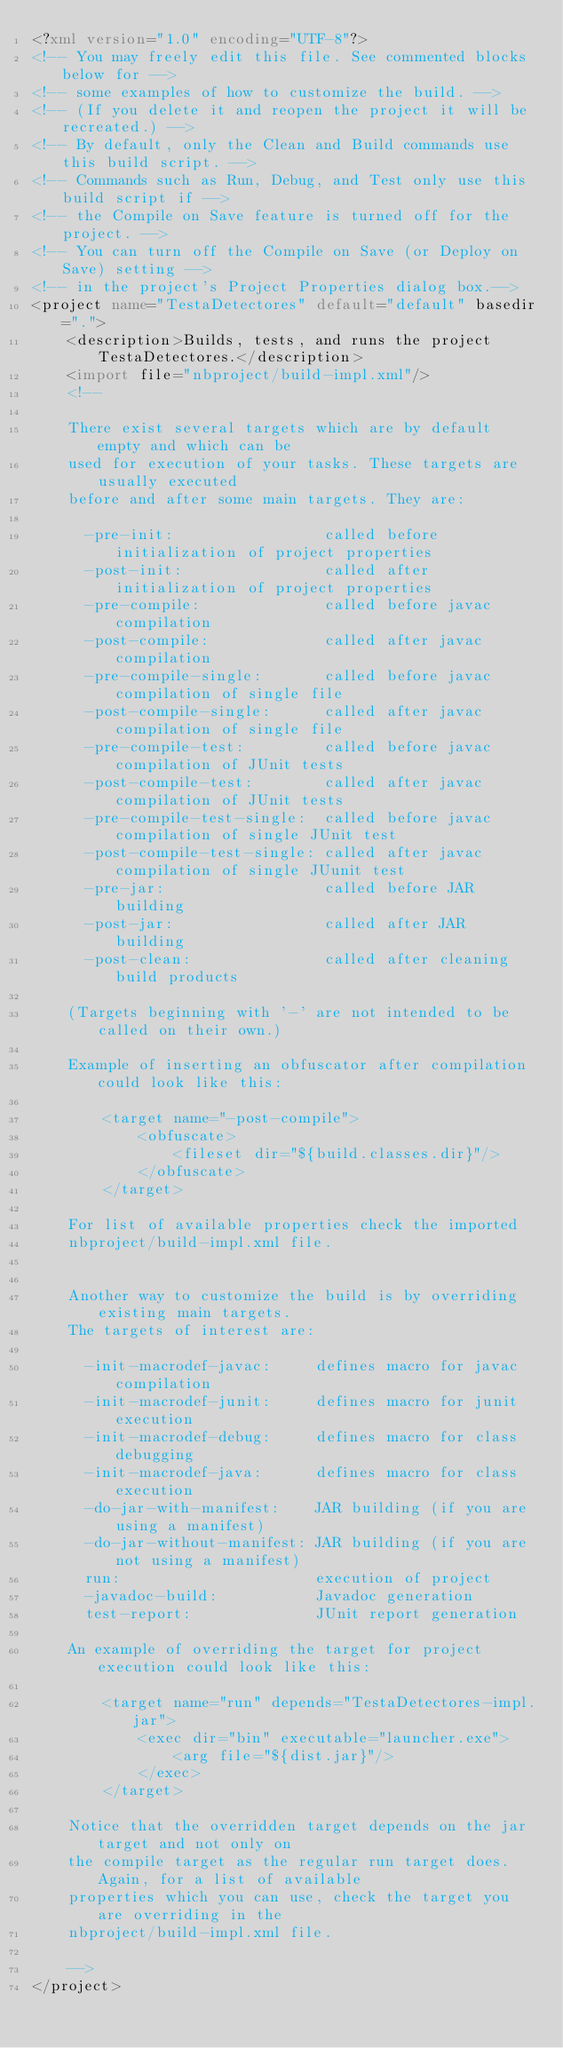<code> <loc_0><loc_0><loc_500><loc_500><_XML_><?xml version="1.0" encoding="UTF-8"?>
<!-- You may freely edit this file. See commented blocks below for -->
<!-- some examples of how to customize the build. -->
<!-- (If you delete it and reopen the project it will be recreated.) -->
<!-- By default, only the Clean and Build commands use this build script. -->
<!-- Commands such as Run, Debug, and Test only use this build script if -->
<!-- the Compile on Save feature is turned off for the project. -->
<!-- You can turn off the Compile on Save (or Deploy on Save) setting -->
<!-- in the project's Project Properties dialog box.-->
<project name="TestaDetectores" default="default" basedir=".">
    <description>Builds, tests, and runs the project TestaDetectores.</description>
    <import file="nbproject/build-impl.xml"/>
    <!--

    There exist several targets which are by default empty and which can be 
    used for execution of your tasks. These targets are usually executed 
    before and after some main targets. They are: 

      -pre-init:                 called before initialization of project properties
      -post-init:                called after initialization of project properties
      -pre-compile:              called before javac compilation
      -post-compile:             called after javac compilation
      -pre-compile-single:       called before javac compilation of single file
      -post-compile-single:      called after javac compilation of single file
      -pre-compile-test:         called before javac compilation of JUnit tests
      -post-compile-test:        called after javac compilation of JUnit tests
      -pre-compile-test-single:  called before javac compilation of single JUnit test
      -post-compile-test-single: called after javac compilation of single JUunit test
      -pre-jar:                  called before JAR building
      -post-jar:                 called after JAR building
      -post-clean:               called after cleaning build products

    (Targets beginning with '-' are not intended to be called on their own.)

    Example of inserting an obfuscator after compilation could look like this:

        <target name="-post-compile">
            <obfuscate>
                <fileset dir="${build.classes.dir}"/>
            </obfuscate>
        </target>

    For list of available properties check the imported 
    nbproject/build-impl.xml file. 


    Another way to customize the build is by overriding existing main targets.
    The targets of interest are: 

      -init-macrodef-javac:     defines macro for javac compilation
      -init-macrodef-junit:     defines macro for junit execution
      -init-macrodef-debug:     defines macro for class debugging
      -init-macrodef-java:      defines macro for class execution
      -do-jar-with-manifest:    JAR building (if you are using a manifest)
      -do-jar-without-manifest: JAR building (if you are not using a manifest)
      run:                      execution of project 
      -javadoc-build:           Javadoc generation
      test-report:              JUnit report generation

    An example of overriding the target for project execution could look like this:

        <target name="run" depends="TestaDetectores-impl.jar">
            <exec dir="bin" executable="launcher.exe">
                <arg file="${dist.jar}"/>
            </exec>
        </target>

    Notice that the overridden target depends on the jar target and not only on 
    the compile target as the regular run target does. Again, for a list of available 
    properties which you can use, check the target you are overriding in the
    nbproject/build-impl.xml file. 

    -->
</project>
</code> 